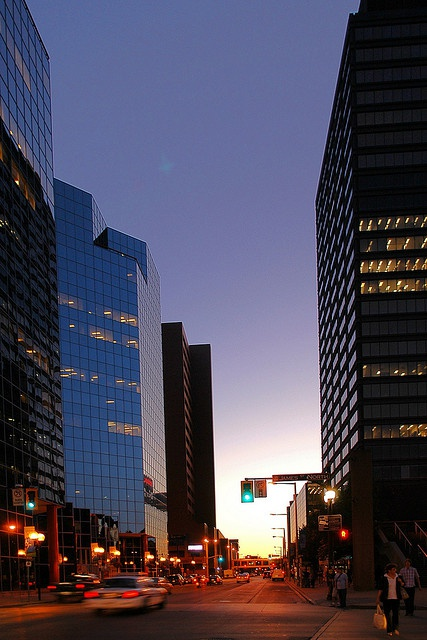Describe the objects in this image and their specific colors. I can see car in darkblue, black, maroon, and brown tones, people in darkblue, black, maroon, and brown tones, car in darkblue, black, maroon, brown, and red tones, people in darkblue, black, maroon, purple, and brown tones, and people in darkblue, black, maroon, and purple tones in this image. 